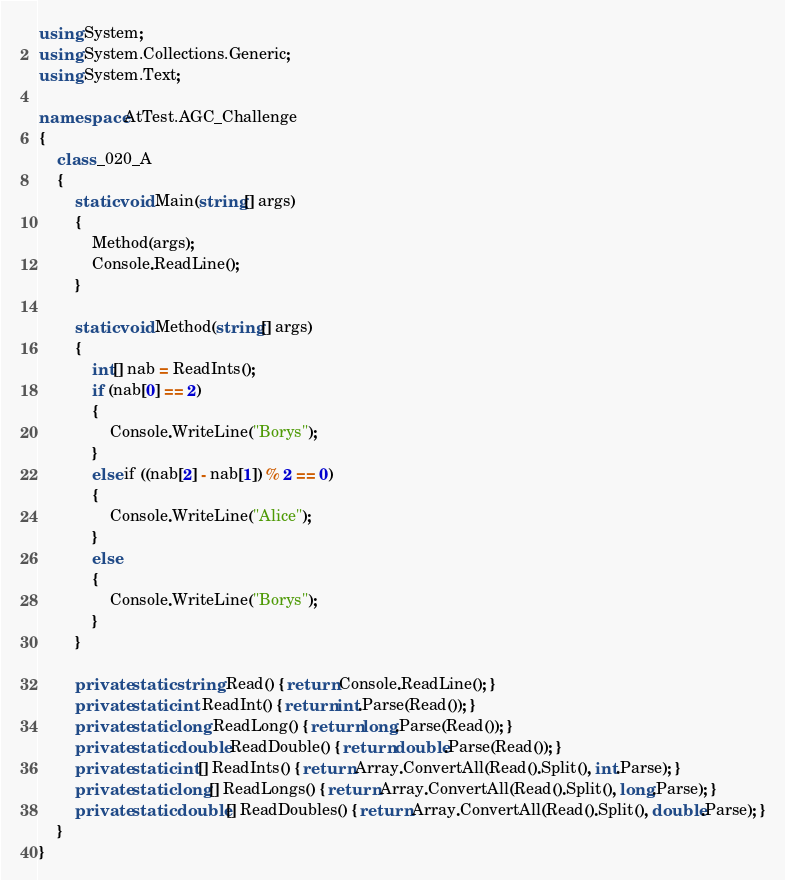<code> <loc_0><loc_0><loc_500><loc_500><_C#_>using System;
using System.Collections.Generic;
using System.Text;

namespace AtTest.AGC_Challenge
{
    class _020_A
    {
        static void Main(string[] args)
        {
            Method(args);
            Console.ReadLine();
        }

        static void Method(string[] args)
        {
            int[] nab = ReadInts();
            if (nab[0] == 2)
            {
                Console.WriteLine("Borys");
            }
            else if ((nab[2] - nab[1]) % 2 == 0)
            {
                Console.WriteLine("Alice");
            }
            else
            {
                Console.WriteLine("Borys");
            }
        }

        private static string Read() { return Console.ReadLine(); }
        private static int ReadInt() { return int.Parse(Read()); }
        private static long ReadLong() { return long.Parse(Read()); }
        private static double ReadDouble() { return double.Parse(Read()); }
        private static int[] ReadInts() { return Array.ConvertAll(Read().Split(), int.Parse); }
        private static long[] ReadLongs() { return Array.ConvertAll(Read().Split(), long.Parse); }
        private static double[] ReadDoubles() { return Array.ConvertAll(Read().Split(), double.Parse); }
    }
}
</code> 